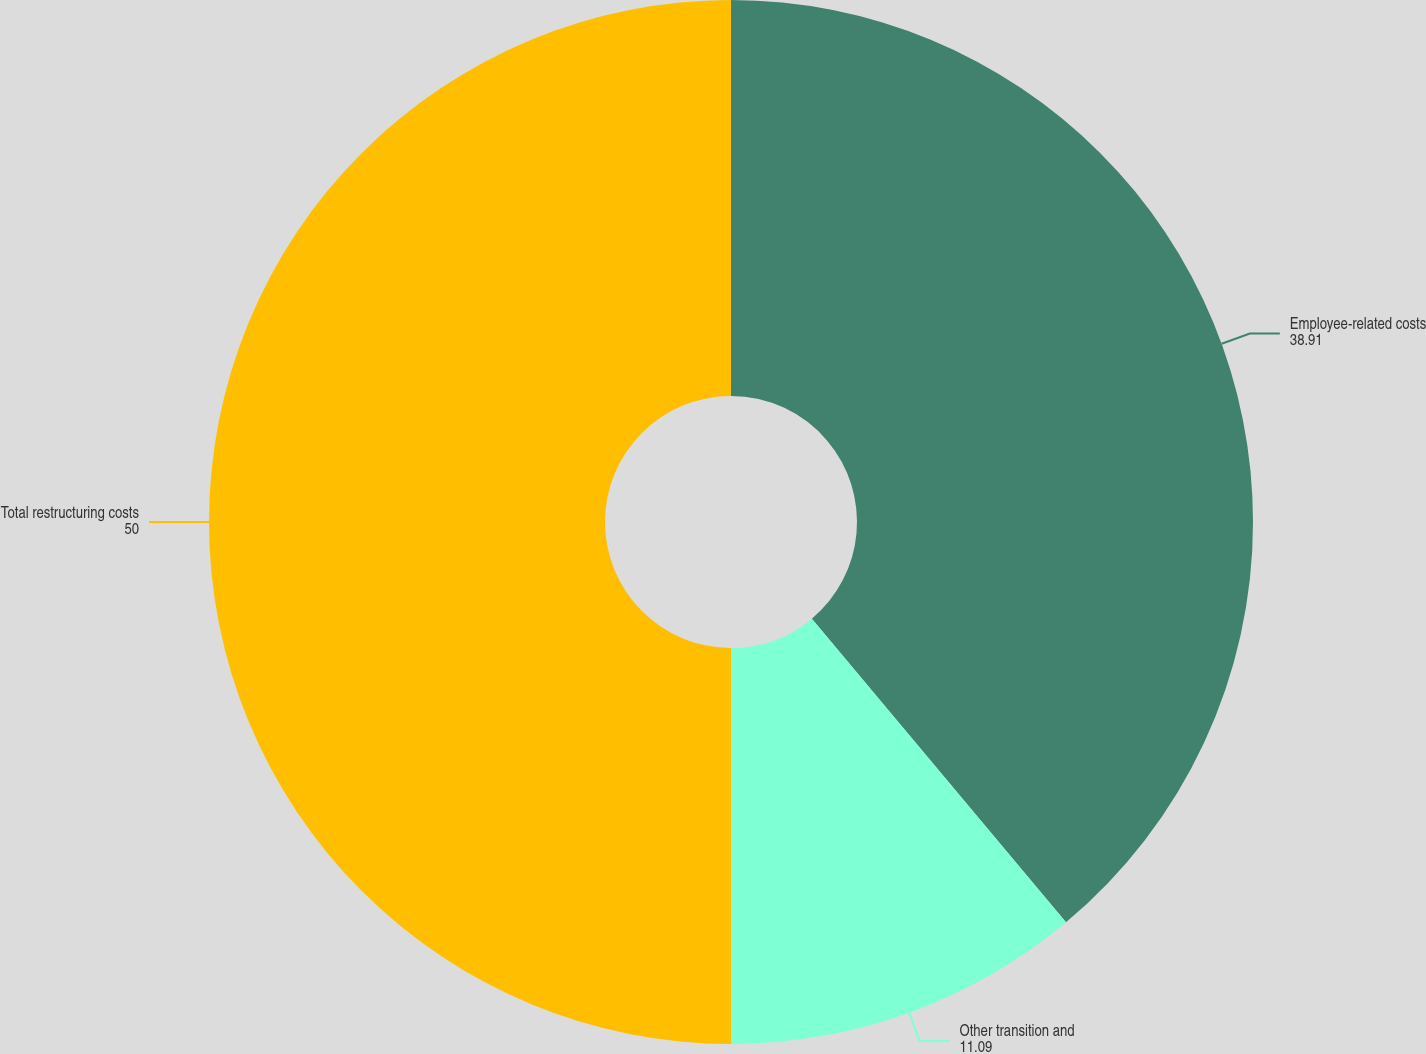Convert chart to OTSL. <chart><loc_0><loc_0><loc_500><loc_500><pie_chart><fcel>Employee-related costs<fcel>Other transition and<fcel>Total restructuring costs<nl><fcel>38.91%<fcel>11.09%<fcel>50.0%<nl></chart> 